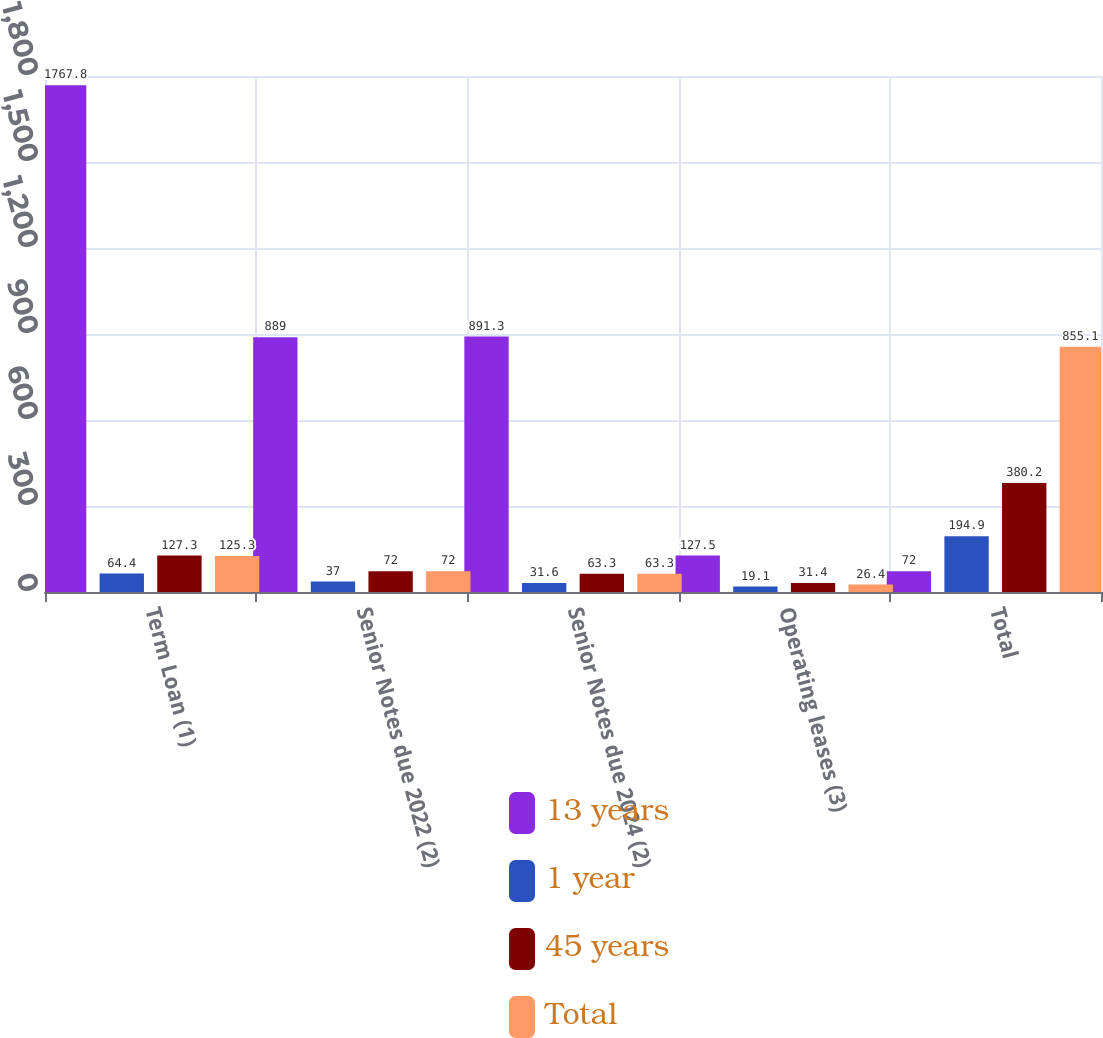Convert chart to OTSL. <chart><loc_0><loc_0><loc_500><loc_500><stacked_bar_chart><ecel><fcel>Term Loan (1)<fcel>Senior Notes due 2022 (2)<fcel>Senior Notes due 2024 (2)<fcel>Operating leases (3)<fcel>Total<nl><fcel>13 years<fcel>1767.8<fcel>889<fcel>891.3<fcel>127.5<fcel>72<nl><fcel>1 year<fcel>64.4<fcel>37<fcel>31.6<fcel>19.1<fcel>194.9<nl><fcel>45 years<fcel>127.3<fcel>72<fcel>63.3<fcel>31.4<fcel>380.2<nl><fcel>Total<fcel>125.3<fcel>72<fcel>63.3<fcel>26.4<fcel>855.1<nl></chart> 